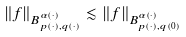Convert formula to latex. <formula><loc_0><loc_0><loc_500><loc_500>\left \| f \right \| _ { B _ { p ( \cdot ) , q ( \cdot ) } ^ { \alpha ( \cdot ) } } \lesssim \left \| f \right \| _ { B _ { p ( \cdot ) , q ( 0 ) } ^ { \alpha ( \cdot ) } }</formula> 